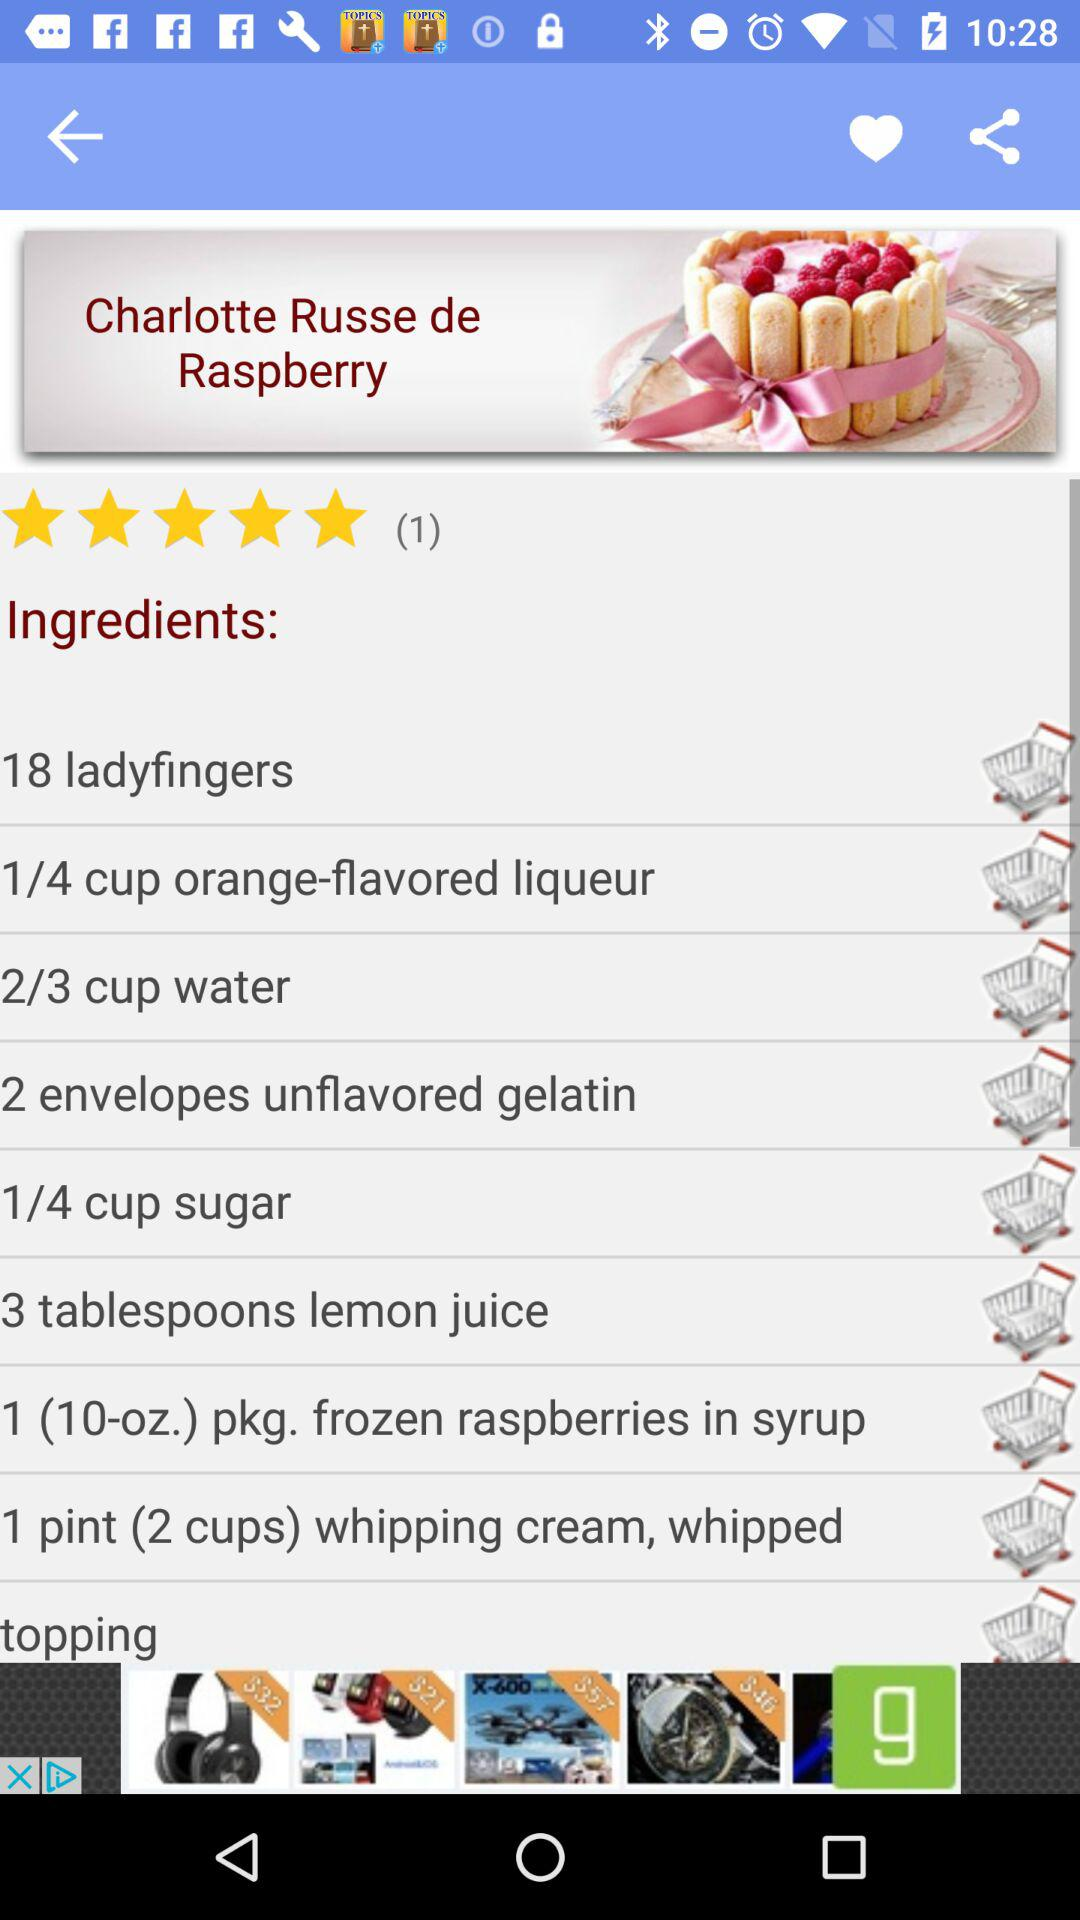What is the rating of "Chartlotte Russe de Raspberry"? The rating of "Chartlotte Russe de Raspberry" is 5 stars. 